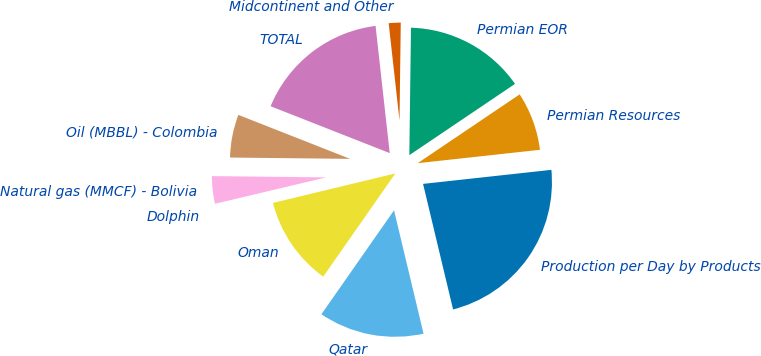Convert chart. <chart><loc_0><loc_0><loc_500><loc_500><pie_chart><fcel>Production per Day by Products<fcel>Permian Resources<fcel>Permian EOR<fcel>Midcontinent and Other<fcel>TOTAL<fcel>Oil (MBBL) - Colombia<fcel>Natural gas (MMCF) - Bolivia<fcel>Dolphin<fcel>Oman<fcel>Qatar<nl><fcel>23.0%<fcel>7.71%<fcel>15.35%<fcel>1.97%<fcel>17.27%<fcel>5.79%<fcel>3.88%<fcel>0.06%<fcel>11.53%<fcel>13.44%<nl></chart> 